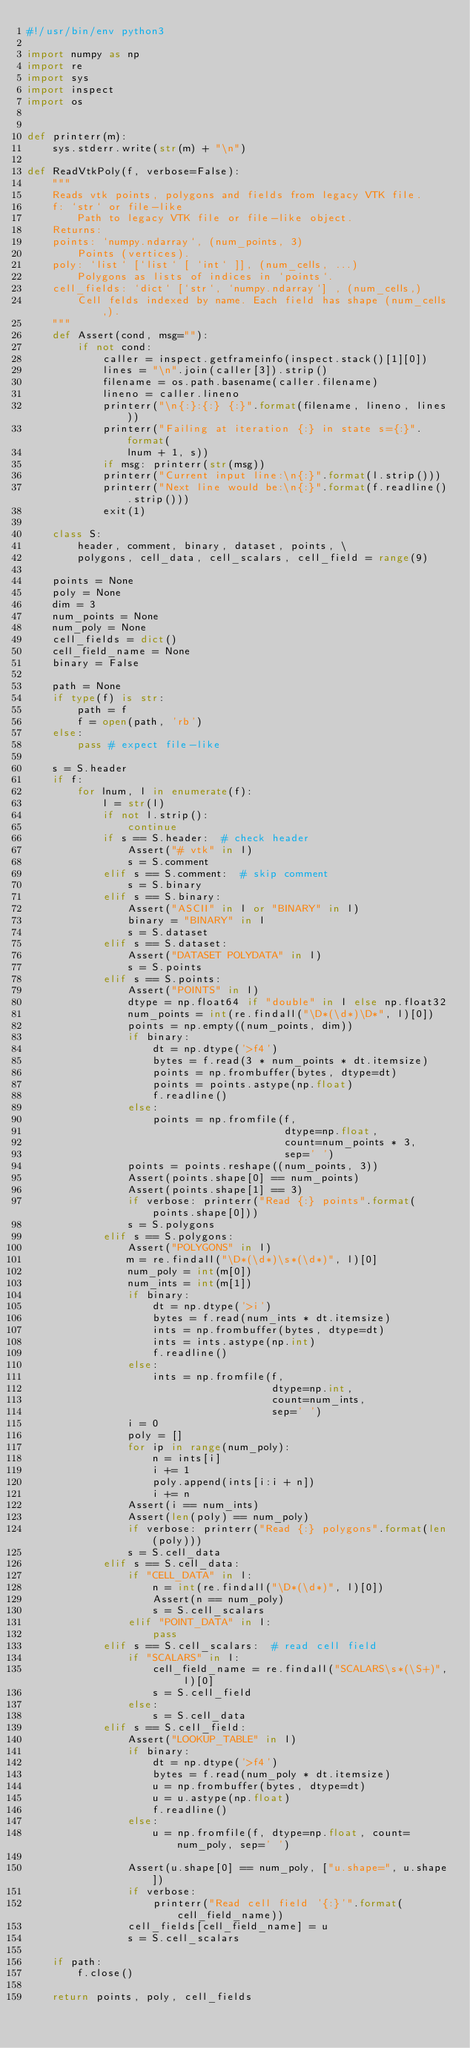<code> <loc_0><loc_0><loc_500><loc_500><_Python_>#!/usr/bin/env python3

import numpy as np
import re
import sys
import inspect
import os


def printerr(m):
    sys.stderr.write(str(m) + "\n")

def ReadVtkPoly(f, verbose=False):
    """
    Reads vtk points, polygons and fields from legacy VTK file.
    f: `str` or file-like
        Path to legacy VTK file or file-like object.
    Returns:
    points: `numpy.ndarray`, (num_points, 3)
        Points (vertices).
    poly: `list` [`list` [ `int` ]], (num_cells, ...)
        Polygons as lists of indices in `points`.
    cell_fields: `dict` [`str`, `numpy.ndarray`] , (num_cells,)
        Cell felds indexed by name. Each field has shape (num_cells,).
    """
    def Assert(cond, msg=""):
        if not cond:
            caller = inspect.getframeinfo(inspect.stack()[1][0])
            lines = "\n".join(caller[3]).strip()
            filename = os.path.basename(caller.filename)
            lineno = caller.lineno
            printerr("\n{:}:{:} {:}".format(filename, lineno, lines))
            printerr("Failing at iteration {:} in state s={:}".format(
                lnum + 1, s))
            if msg: printerr(str(msg))
            printerr("Current input line:\n{:}".format(l.strip()))
            printerr("Next line would be:\n{:}".format(f.readline().strip()))
            exit(1)

    class S:
        header, comment, binary, dataset, points, \
        polygons, cell_data, cell_scalars, cell_field = range(9)

    points = None
    poly = None
    dim = 3
    num_points = None
    num_poly = None
    cell_fields = dict()
    cell_field_name = None
    binary = False

    path = None
    if type(f) is str:
        path = f
        f = open(path, 'rb')
    else:
        pass # expect file-like

    s = S.header
    if f:
        for lnum, l in enumerate(f):
            l = str(l)
            if not l.strip():
                continue
            if s == S.header:  # check header
                Assert("# vtk" in l)
                s = S.comment
            elif s == S.comment:  # skip comment
                s = S.binary
            elif s == S.binary:
                Assert("ASCII" in l or "BINARY" in l)
                binary = "BINARY" in l
                s = S.dataset
            elif s == S.dataset:
                Assert("DATASET POLYDATA" in l)
                s = S.points
            elif s == S.points:
                Assert("POINTS" in l)
                dtype = np.float64 if "double" in l else np.float32
                num_points = int(re.findall("\D*(\d*)\D*", l)[0])
                points = np.empty((num_points, dim))
                if binary:
                    dt = np.dtype('>f4')
                    bytes = f.read(3 * num_points * dt.itemsize)
                    points = np.frombuffer(bytes, dtype=dt)
                    points = points.astype(np.float)
                    f.readline()
                else:
                    points = np.fromfile(f,
                                         dtype=np.float,
                                         count=num_points * 3,
                                         sep=' ')
                points = points.reshape((num_points, 3))
                Assert(points.shape[0] == num_points)
                Assert(points.shape[1] == 3)
                if verbose: printerr("Read {:} points".format(points.shape[0]))
                s = S.polygons
            elif s == S.polygons:
                Assert("POLYGONS" in l)
                m = re.findall("\D*(\d*)\s*(\d*)", l)[0]
                num_poly = int(m[0])
                num_ints = int(m[1])
                if binary:
                    dt = np.dtype('>i')
                    bytes = f.read(num_ints * dt.itemsize)
                    ints = np.frombuffer(bytes, dtype=dt)
                    ints = ints.astype(np.int)
                    f.readline()
                else:
                    ints = np.fromfile(f,
                                       dtype=np.int,
                                       count=num_ints,
                                       sep=' ')
                i = 0
                poly = []
                for ip in range(num_poly):
                    n = ints[i]
                    i += 1
                    poly.append(ints[i:i + n])
                    i += n
                Assert(i == num_ints)
                Assert(len(poly) == num_poly)
                if verbose: printerr("Read {:} polygons".format(len(poly)))
                s = S.cell_data
            elif s == S.cell_data:
                if "CELL_DATA" in l:
                    n = int(re.findall("\D*(\d*)", l)[0])
                    Assert(n == num_poly)
                    s = S.cell_scalars
                elif "POINT_DATA" in l:
                    pass
            elif s == S.cell_scalars:  # read cell field
                if "SCALARS" in l:
                    cell_field_name = re.findall("SCALARS\s*(\S+)", l)[0]
                    s = S.cell_field
                else:
                    s = S.cell_data
            elif s == S.cell_field:
                Assert("LOOKUP_TABLE" in l)
                if binary:
                    dt = np.dtype('>f4')
                    bytes = f.read(num_poly * dt.itemsize)
                    u = np.frombuffer(bytes, dtype=dt)
                    u = u.astype(np.float)
                    f.readline()
                else:
                    u = np.fromfile(f, dtype=np.float, count=num_poly, sep=' ')

                Assert(u.shape[0] == num_poly, ["u.shape=", u.shape])
                if verbose:
                    printerr("Read cell field '{:}'".format(cell_field_name))
                cell_fields[cell_field_name] = u
                s = S.cell_scalars

    if path:
        f.close()

    return points, poly, cell_fields
</code> 